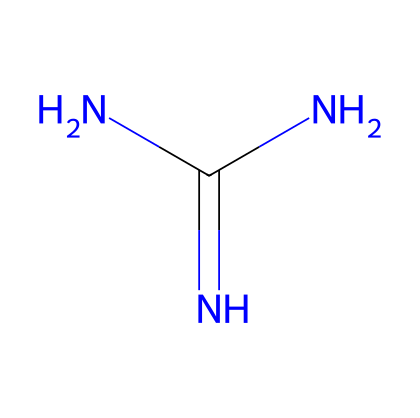What is the molecular formula of guanidine? The SMILES representation indicates that the molecule contains one carbon atom (C), three nitrogen atoms (N), and one hydrogen atom (H) in its structure. Therefore, the molecular formula can be deduced as C1H7N5.
Answer: C1H7N5 How many hydrogen atoms are present in guanidine? From the SMILES representation, we can count the total number of hydrogen atoms attached to the nitrogen and carbon atoms within the structure, which sums up to seven hydrogen atoms.
Answer: 7 What functional group is present in guanidine? The structure reveals that guanidine contains an amine group (N), indicated by the presence of multiple nitrogen atoms. This classifies guanidine as containing primary amines due to the nitrogen atoms' bonding arrangement.
Answer: amine What type of bonding is primarily responsible for guanidine's basicity? The basicity is predominantly attributed to the lone pairs of electrons on the nitrogen atoms, enabling them to accept protons (H+). This characteristic stems from the arrangement indicated in the structure.
Answer: electron donation How does the presence of three nitrogen atoms influence guanidine's properties? The three nitrogen atoms provide a higher electron density, which enhances the molecule's ability to act as a superbase since more lone pairs are available for protonation, increasing reactivity and basicity.
Answer: increased basicity What is the hybridization state of the central carbon atom in guanidine? By analyzing the connectivity of the carbon atom in the guanidine structure, it is bonded to one nitrogen (with double bond) and two nitrogen atoms (with single bonds), suggesting a trigonal planar arrangement, which corresponds to sp2 hybridization.
Answer: sp2 